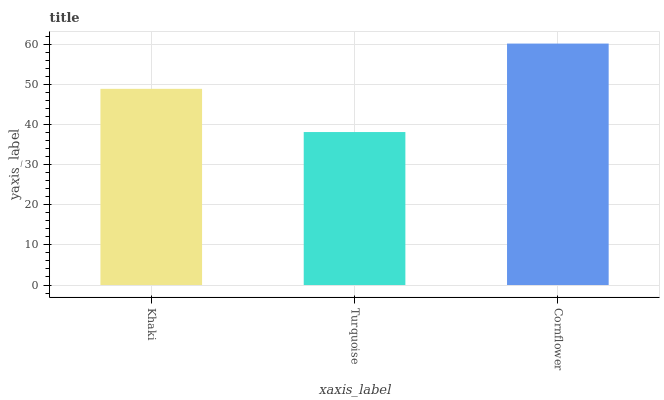Is Turquoise the minimum?
Answer yes or no. Yes. Is Cornflower the maximum?
Answer yes or no. Yes. Is Cornflower the minimum?
Answer yes or no. No. Is Turquoise the maximum?
Answer yes or no. No. Is Cornflower greater than Turquoise?
Answer yes or no. Yes. Is Turquoise less than Cornflower?
Answer yes or no. Yes. Is Turquoise greater than Cornflower?
Answer yes or no. No. Is Cornflower less than Turquoise?
Answer yes or no. No. Is Khaki the high median?
Answer yes or no. Yes. Is Khaki the low median?
Answer yes or no. Yes. Is Turquoise the high median?
Answer yes or no. No. Is Cornflower the low median?
Answer yes or no. No. 